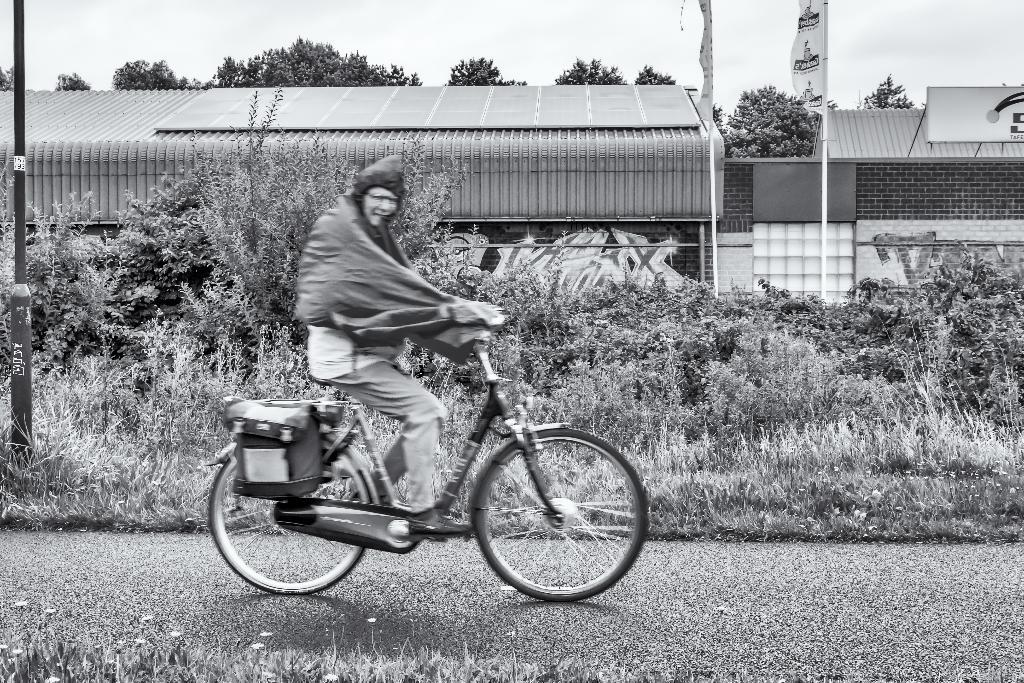What is the man in the image doing? The man is riding a bicycle in the image. What can be seen in the background of the image? There are plants, a tree, a building, hoardings, and the sky visible in the background of the image. What type of hook can be seen hanging from the wire in the image? There is no hook or wire present in the image. Can you see any chickens in the image? There are no chickens present in the image. 